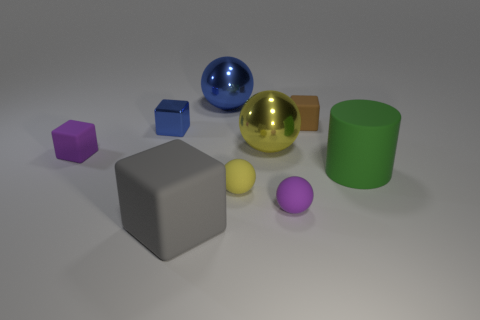What material is the yellow thing that is the same size as the blue ball?
Make the answer very short. Metal. How many objects are either large blue rubber cylinders or yellow things that are behind the purple block?
Offer a terse response. 1. There is a purple sphere; does it have the same size as the blue block that is in front of the tiny brown rubber block?
Keep it short and to the point. Yes. How many spheres are purple things or rubber things?
Your answer should be compact. 2. How many blocks are both behind the large cylinder and to the left of the brown rubber cube?
Your answer should be very brief. 2. How many other things are there of the same color as the metallic block?
Provide a short and direct response. 1. What shape is the blue object behind the brown matte thing?
Give a very brief answer. Sphere. Are the small purple cube and the brown object made of the same material?
Offer a very short reply. Yes. What number of rubber cylinders are behind the tiny brown cube?
Keep it short and to the point. 0. There is a big metallic thing behind the tiny cube that is on the right side of the small blue thing; what shape is it?
Provide a short and direct response. Sphere. 